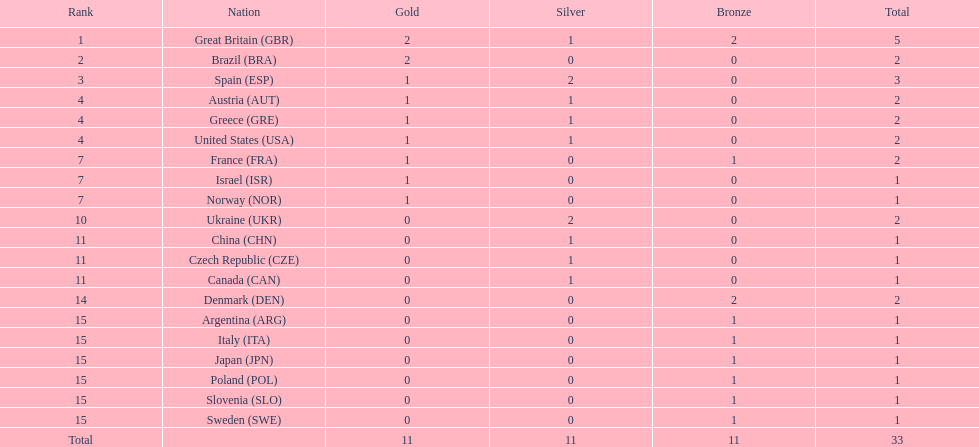Which country won the most medals total? Great Britain (GBR). 